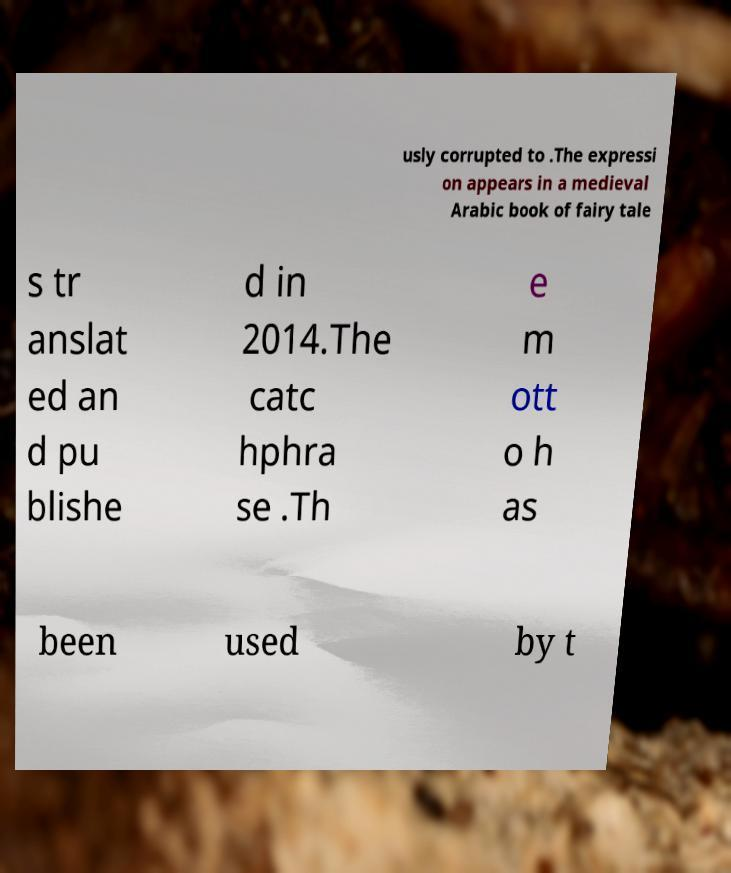Please identify and transcribe the text found in this image. usly corrupted to .The expressi on appears in a medieval Arabic book of fairy tale s tr anslat ed an d pu blishe d in 2014.The catc hphra se .Th e m ott o h as been used by t 